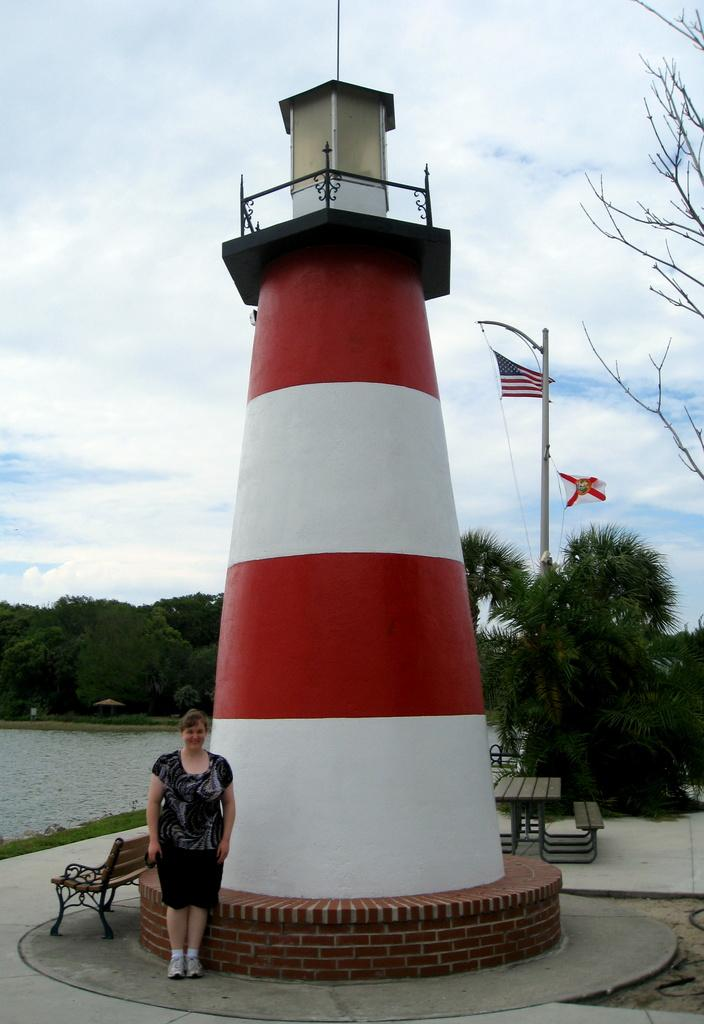What is the main subject of the image? There is a woman standing in the image. What can be seen in the background of the image? There are benches, a table, flags, trees, water, a tower, and the sky visible in the background of the image. What type of team is shown receiving approval from the woman in the image? There is no team or approval process depicted in the image; it only features a woman standing and various elements in the background. 